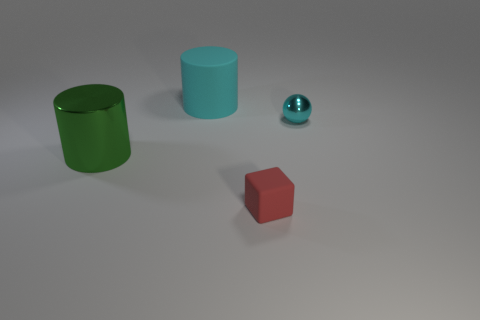Add 1 small things. How many objects exist? 5 Subtract all cubes. How many objects are left? 3 Add 1 red cubes. How many red cubes are left? 2 Add 2 tiny balls. How many tiny balls exist? 3 Subtract 0 green blocks. How many objects are left? 4 Subtract all tiny objects. Subtract all large purple cubes. How many objects are left? 2 